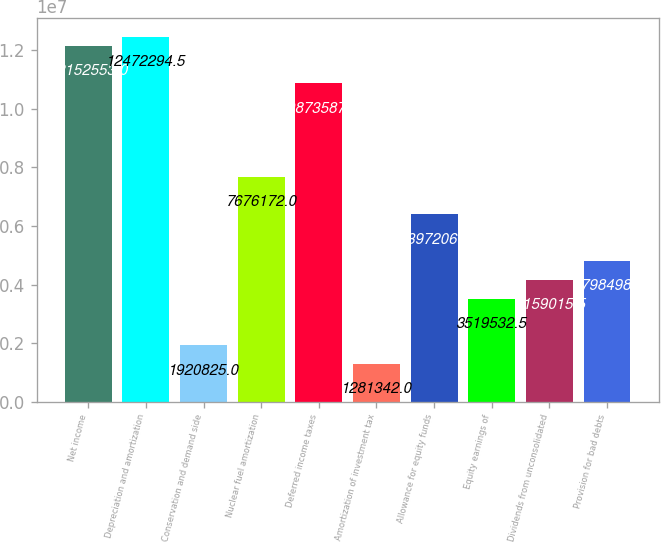Convert chart. <chart><loc_0><loc_0><loc_500><loc_500><bar_chart><fcel>Net income<fcel>Depreciation and amortization<fcel>Conservation and demand side<fcel>Nuclear fuel amortization<fcel>Deferred income taxes<fcel>Amortization of investment tax<fcel>Allowance for equity funds<fcel>Equity earnings of<fcel>Dividends from unconsolidated<fcel>Provision for bad debts<nl><fcel>1.21526e+07<fcel>1.24723e+07<fcel>1.92082e+06<fcel>7.67617e+06<fcel>1.08736e+07<fcel>1.28134e+06<fcel>6.39721e+06<fcel>3.51953e+06<fcel>4.15902e+06<fcel>4.7985e+06<nl></chart> 